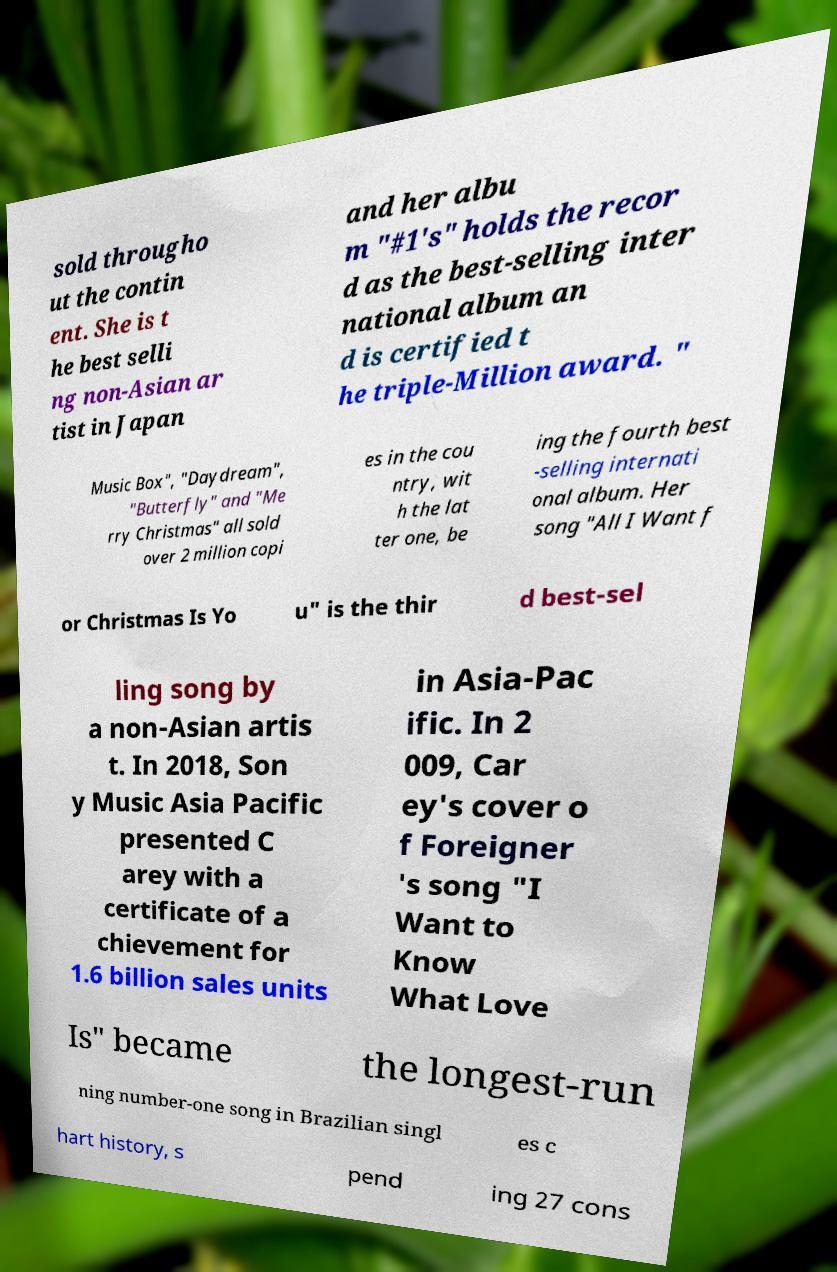Please read and relay the text visible in this image. What does it say? sold througho ut the contin ent. She is t he best selli ng non-Asian ar tist in Japan and her albu m "#1's" holds the recor d as the best-selling inter national album an d is certified t he triple-Million award. " Music Box", "Daydream", "Butterfly" and "Me rry Christmas" all sold over 2 million copi es in the cou ntry, wit h the lat ter one, be ing the fourth best -selling internati onal album. Her song "All I Want f or Christmas Is Yo u" is the thir d best-sel ling song by a non-Asian artis t. In 2018, Son y Music Asia Pacific presented C arey with a certificate of a chievement for 1.6 billion sales units in Asia-Pac ific. In 2 009, Car ey's cover o f Foreigner 's song "I Want to Know What Love Is" became the longest-run ning number-one song in Brazilian singl es c hart history, s pend ing 27 cons 